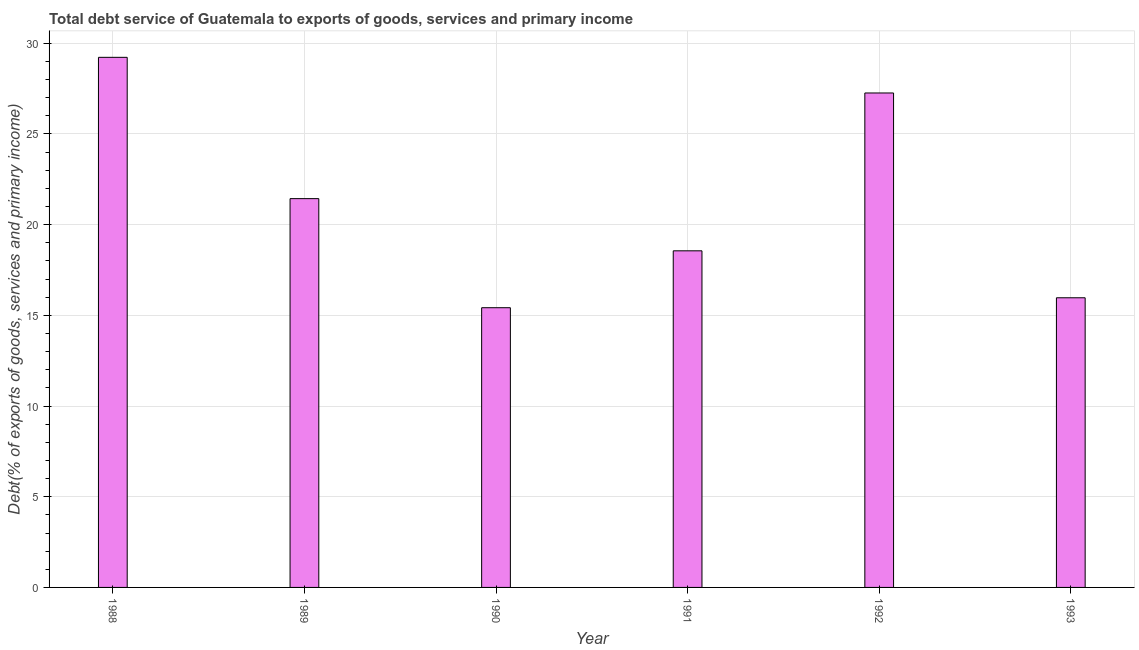Does the graph contain any zero values?
Your response must be concise. No. What is the title of the graph?
Make the answer very short. Total debt service of Guatemala to exports of goods, services and primary income. What is the label or title of the X-axis?
Keep it short and to the point. Year. What is the label or title of the Y-axis?
Your answer should be very brief. Debt(% of exports of goods, services and primary income). What is the total debt service in 1988?
Ensure brevity in your answer.  29.22. Across all years, what is the maximum total debt service?
Make the answer very short. 29.22. Across all years, what is the minimum total debt service?
Give a very brief answer. 15.42. In which year was the total debt service maximum?
Your response must be concise. 1988. What is the sum of the total debt service?
Your response must be concise. 127.85. What is the difference between the total debt service in 1988 and 1990?
Offer a very short reply. 13.8. What is the average total debt service per year?
Offer a very short reply. 21.31. What is the median total debt service?
Keep it short and to the point. 19.99. What is the ratio of the total debt service in 1990 to that in 1992?
Provide a succinct answer. 0.57. What is the difference between the highest and the second highest total debt service?
Offer a terse response. 1.97. What is the difference between the highest and the lowest total debt service?
Your answer should be compact. 13.8. In how many years, is the total debt service greater than the average total debt service taken over all years?
Provide a succinct answer. 3. Are the values on the major ticks of Y-axis written in scientific E-notation?
Your answer should be compact. No. What is the Debt(% of exports of goods, services and primary income) of 1988?
Provide a short and direct response. 29.22. What is the Debt(% of exports of goods, services and primary income) of 1989?
Your response must be concise. 21.43. What is the Debt(% of exports of goods, services and primary income) in 1990?
Offer a very short reply. 15.42. What is the Debt(% of exports of goods, services and primary income) in 1991?
Keep it short and to the point. 18.56. What is the Debt(% of exports of goods, services and primary income) of 1992?
Ensure brevity in your answer.  27.26. What is the Debt(% of exports of goods, services and primary income) in 1993?
Provide a short and direct response. 15.97. What is the difference between the Debt(% of exports of goods, services and primary income) in 1988 and 1989?
Provide a succinct answer. 7.79. What is the difference between the Debt(% of exports of goods, services and primary income) in 1988 and 1990?
Your answer should be very brief. 13.8. What is the difference between the Debt(% of exports of goods, services and primary income) in 1988 and 1991?
Provide a succinct answer. 10.67. What is the difference between the Debt(% of exports of goods, services and primary income) in 1988 and 1992?
Provide a short and direct response. 1.96. What is the difference between the Debt(% of exports of goods, services and primary income) in 1988 and 1993?
Keep it short and to the point. 13.25. What is the difference between the Debt(% of exports of goods, services and primary income) in 1989 and 1990?
Your answer should be very brief. 6.01. What is the difference between the Debt(% of exports of goods, services and primary income) in 1989 and 1991?
Your response must be concise. 2.88. What is the difference between the Debt(% of exports of goods, services and primary income) in 1989 and 1992?
Keep it short and to the point. -5.82. What is the difference between the Debt(% of exports of goods, services and primary income) in 1989 and 1993?
Your answer should be compact. 5.47. What is the difference between the Debt(% of exports of goods, services and primary income) in 1990 and 1991?
Offer a terse response. -3.14. What is the difference between the Debt(% of exports of goods, services and primary income) in 1990 and 1992?
Give a very brief answer. -11.84. What is the difference between the Debt(% of exports of goods, services and primary income) in 1990 and 1993?
Offer a terse response. -0.55. What is the difference between the Debt(% of exports of goods, services and primary income) in 1991 and 1992?
Offer a terse response. -8.7. What is the difference between the Debt(% of exports of goods, services and primary income) in 1991 and 1993?
Your answer should be compact. 2.59. What is the difference between the Debt(% of exports of goods, services and primary income) in 1992 and 1993?
Provide a succinct answer. 11.29. What is the ratio of the Debt(% of exports of goods, services and primary income) in 1988 to that in 1989?
Your answer should be compact. 1.36. What is the ratio of the Debt(% of exports of goods, services and primary income) in 1988 to that in 1990?
Your answer should be very brief. 1.9. What is the ratio of the Debt(% of exports of goods, services and primary income) in 1988 to that in 1991?
Offer a terse response. 1.57. What is the ratio of the Debt(% of exports of goods, services and primary income) in 1988 to that in 1992?
Your answer should be compact. 1.07. What is the ratio of the Debt(% of exports of goods, services and primary income) in 1988 to that in 1993?
Offer a terse response. 1.83. What is the ratio of the Debt(% of exports of goods, services and primary income) in 1989 to that in 1990?
Offer a terse response. 1.39. What is the ratio of the Debt(% of exports of goods, services and primary income) in 1989 to that in 1991?
Keep it short and to the point. 1.16. What is the ratio of the Debt(% of exports of goods, services and primary income) in 1989 to that in 1992?
Keep it short and to the point. 0.79. What is the ratio of the Debt(% of exports of goods, services and primary income) in 1989 to that in 1993?
Provide a short and direct response. 1.34. What is the ratio of the Debt(% of exports of goods, services and primary income) in 1990 to that in 1991?
Ensure brevity in your answer.  0.83. What is the ratio of the Debt(% of exports of goods, services and primary income) in 1990 to that in 1992?
Give a very brief answer. 0.57. What is the ratio of the Debt(% of exports of goods, services and primary income) in 1990 to that in 1993?
Your response must be concise. 0.97. What is the ratio of the Debt(% of exports of goods, services and primary income) in 1991 to that in 1992?
Your response must be concise. 0.68. What is the ratio of the Debt(% of exports of goods, services and primary income) in 1991 to that in 1993?
Provide a succinct answer. 1.16. What is the ratio of the Debt(% of exports of goods, services and primary income) in 1992 to that in 1993?
Offer a terse response. 1.71. 